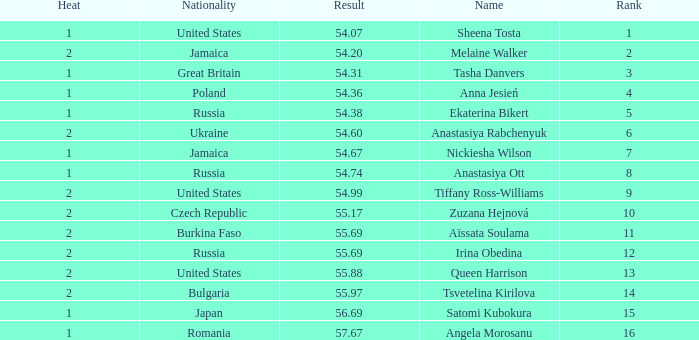Which Heat has a Nationality of bulgaria, and a Result larger than 55.97? None. 